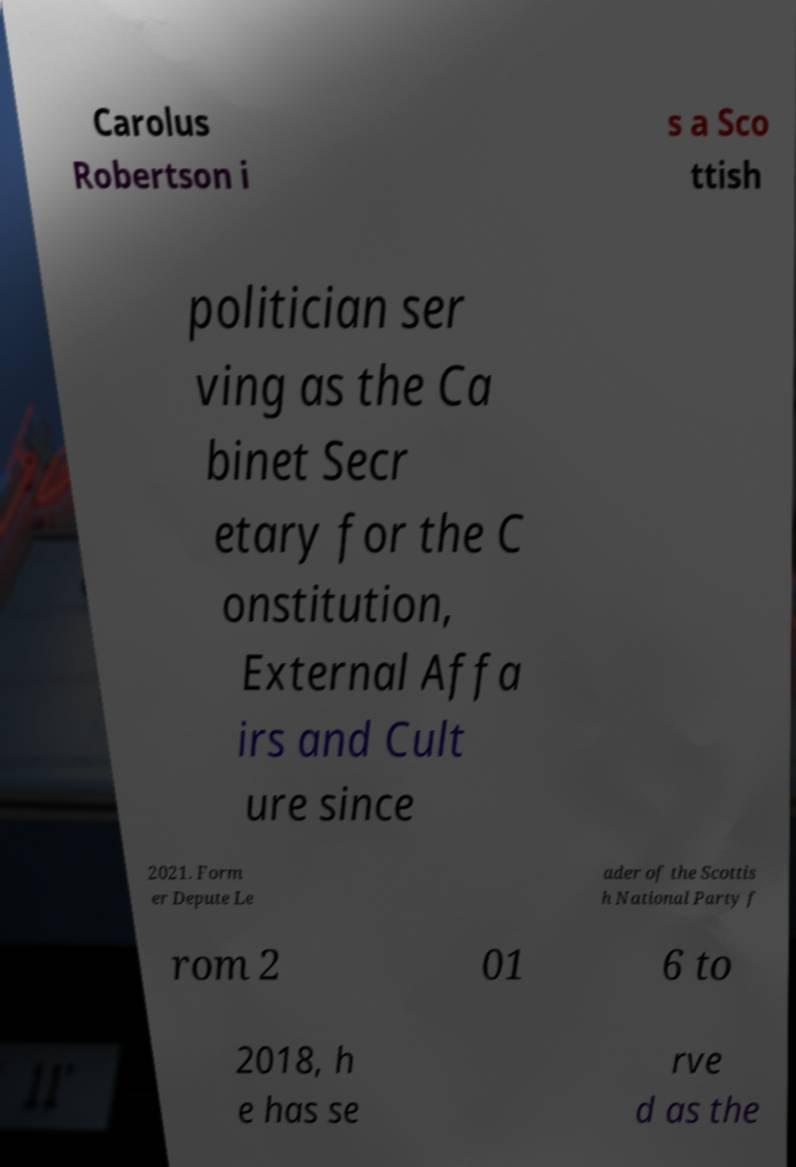There's text embedded in this image that I need extracted. Can you transcribe it verbatim? Carolus Robertson i s a Sco ttish politician ser ving as the Ca binet Secr etary for the C onstitution, External Affa irs and Cult ure since 2021. Form er Depute Le ader of the Scottis h National Party f rom 2 01 6 to 2018, h e has se rve d as the 